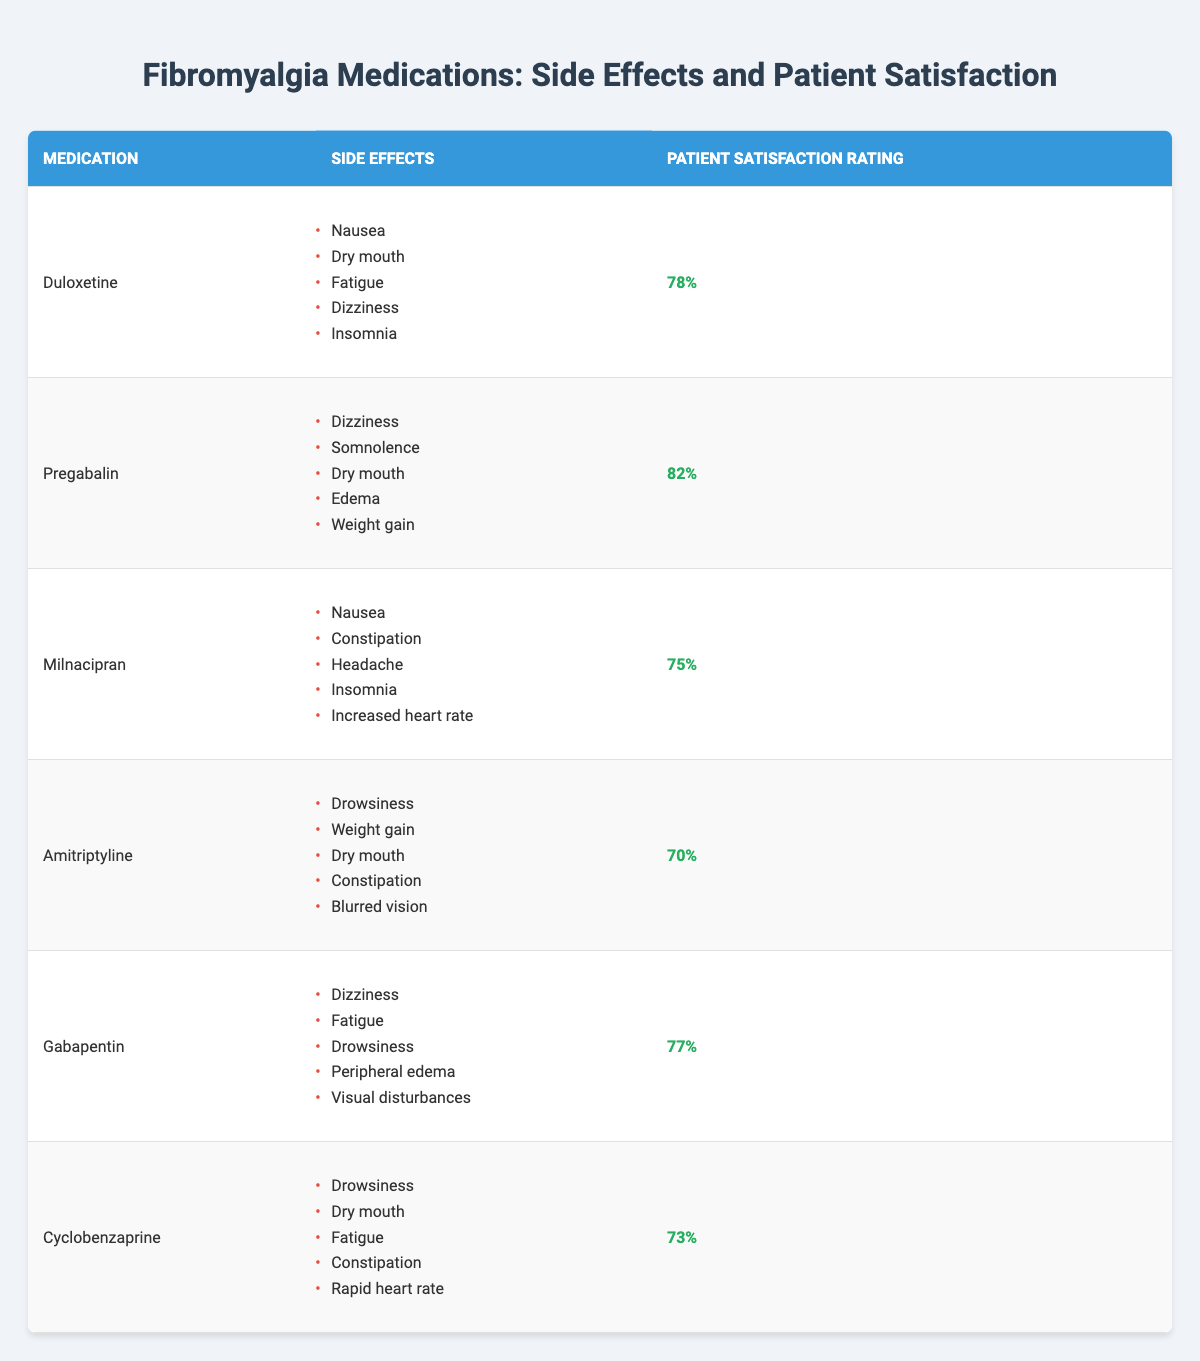What are the side effects of Duloxetine? The side effects listed for Duloxetine in the table are: Nausea, Dry mouth, Fatigue, Dizziness, and Insomnia.
Answer: Nausea, Dry mouth, Fatigue, Dizziness, Insomnia Which medication has the highest patient satisfaction rating? By comparing the patient satisfaction ratings from the table, Pregabalin has the highest rating at 82%.
Answer: Pregabalin Is the patient satisfaction rating for Amitriptyline above 75%? The located satisfaction rating for Amitriptyline is 70%, which is less than 75%, so the statement is false.
Answer: No How many medications have a patient satisfaction rating of 75% or higher? The medications with satisfaction ratings of 75% or higher are Duloxetine (78%), Pregabalin (82%), and Gabapentin (77%), totaling three medications.
Answer: 3 What is the average patient satisfaction rating for the listed medications? The ratings are 78, 82, 75, 70, 77, and 73. Their sum is 455. Divided by the number of medications (6), the average is 455/6 = 75.83.
Answer: 75.83 Which medication has the lowest patient satisfaction rating and what are its side effects? The medication with the lowest satisfaction rating is Amitriptyline (70%). Its side effects are Drowsiness, Weight gain, Dry mouth, Constipation, and Blurred vision.
Answer: Amitriptyline: Drowsiness, Weight gain, Dry mouth, Constipation, Blurred vision Are there any medications that cause both Dizziness and Dry mouth as side effects? Checking the side effects for each medication, both Duloxetine and Pregabalin list Dizziness and Dry mouth as side effects.
Answer: Yes What is the difference in patient satisfaction ratings between Pregabalin and Cyclobenzaprine? Pregabalin has a rating of 82% and Cyclobenzaprine has 73%. The difference is 82 - 73 = 9.
Answer: 9 How many medications list 'Drowsiness' as a side effect? The medications that list 'Drowsiness' as a side effect are Amitriptyline, Gabapentin, and Cyclobenzaprine, totaling three medications.
Answer: 3 Does Milnacipran have 'Constipation' as a side effect? According to the table, Milnacipran does include 'Constipation' among its listed side effects, so the answer is yes.
Answer: Yes Which medication has a higher dissatisfaction threshold, the one with the lowest rating or the one with the highest rating? With the lowest rating of 70% (Amitriptyline) and the highest rating of 82% (Pregabalin), Amitriptyline has a higher dissatisfaction threshold (lower rating means higher dissatisfaction).
Answer: Amitriptyline 